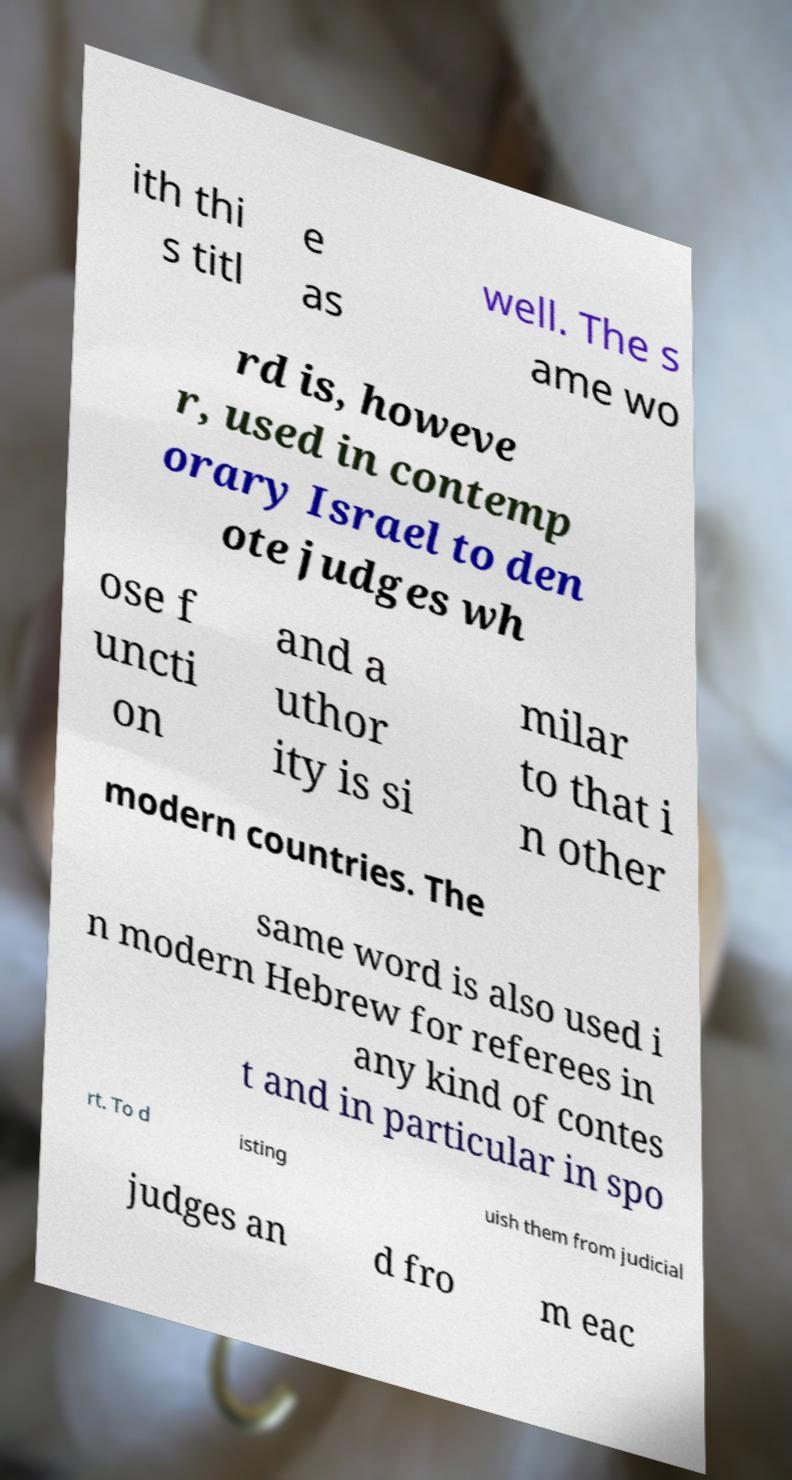What messages or text are displayed in this image? I need them in a readable, typed format. ith thi s titl e as well. The s ame wo rd is, howeve r, used in contemp orary Israel to den ote judges wh ose f uncti on and a uthor ity is si milar to that i n other modern countries. The same word is also used i n modern Hebrew for referees in any kind of contes t and in particular in spo rt. To d isting uish them from judicial judges an d fro m eac 